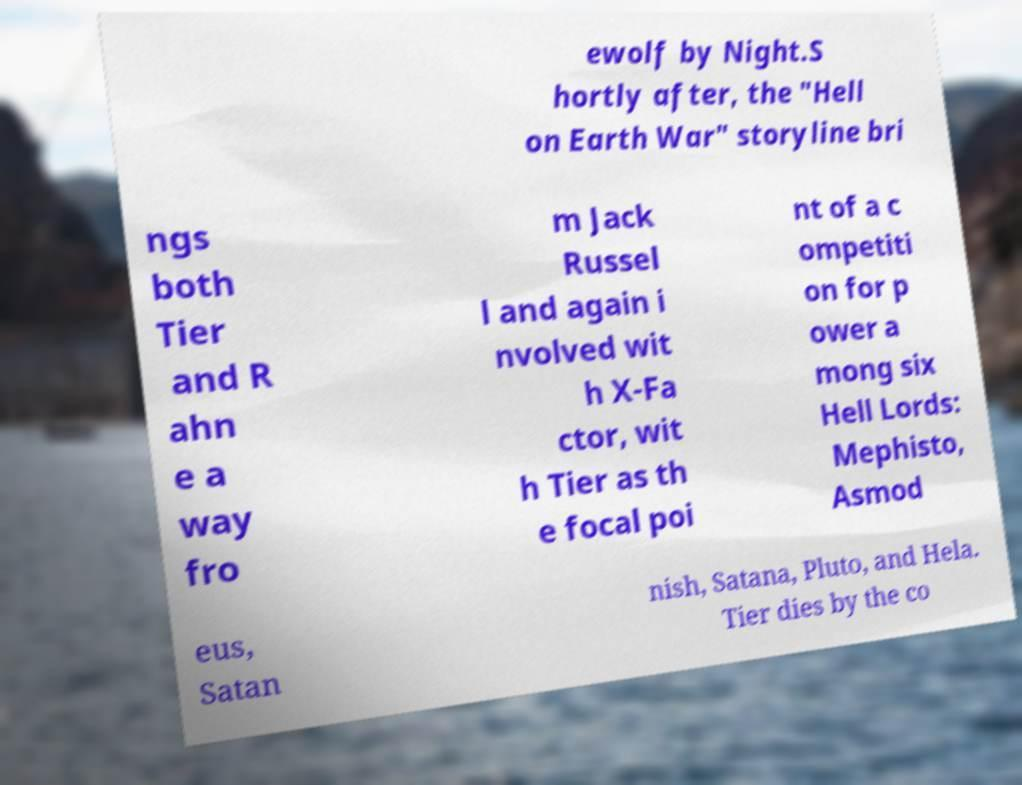Can you read and provide the text displayed in the image?This photo seems to have some interesting text. Can you extract and type it out for me? ewolf by Night.S hortly after, the "Hell on Earth War" storyline bri ngs both Tier and R ahn e a way fro m Jack Russel l and again i nvolved wit h X-Fa ctor, wit h Tier as th e focal poi nt of a c ompetiti on for p ower a mong six Hell Lords: Mephisto, Asmod eus, Satan nish, Satana, Pluto, and Hela. Tier dies by the co 